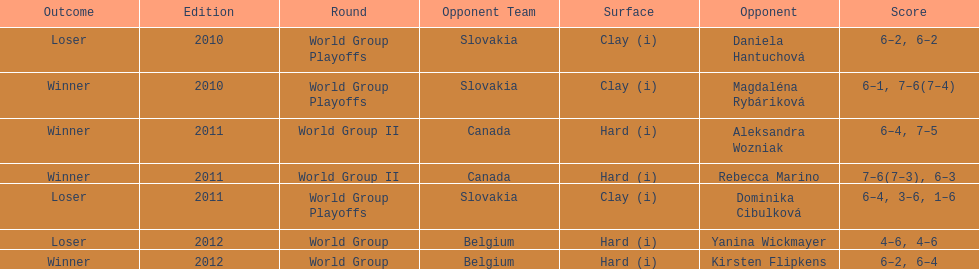Total games in the showdown with dominika cibulkova? 3. 